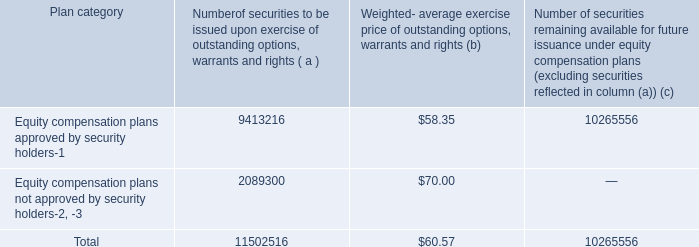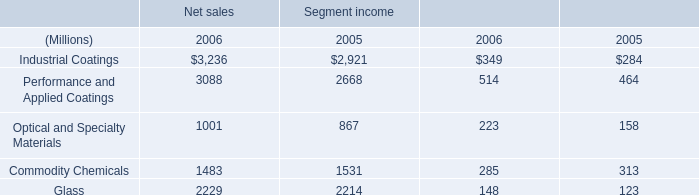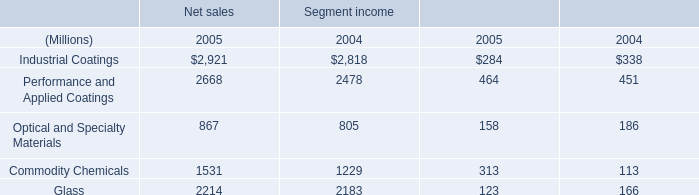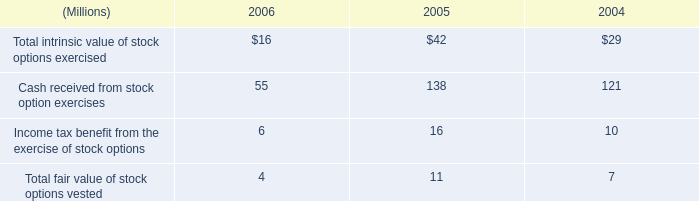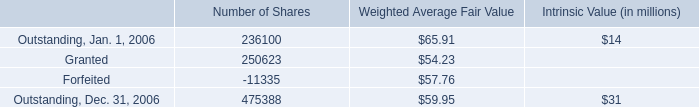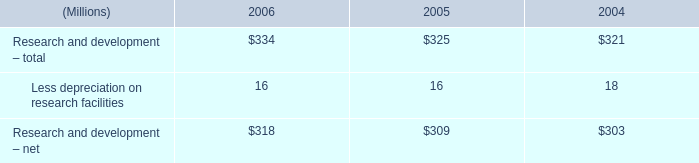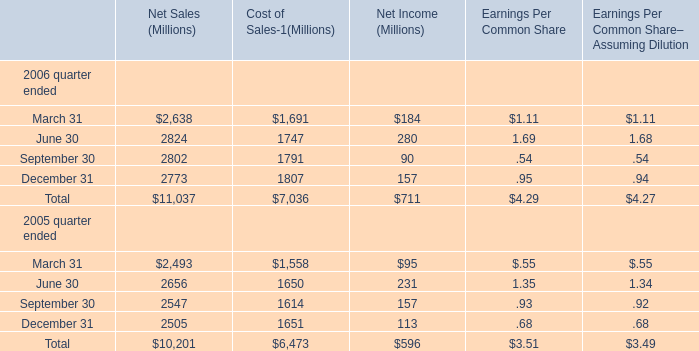What is the average amount of Optical and Specialty Materials of Net sales 2006, and Commodity Chemicals of Segment income 2004 ? 
Computations: ((1001.0 + 1229.0) / 2)
Answer: 1115.0. 